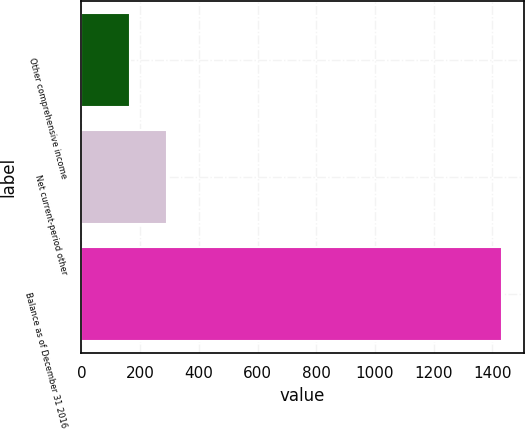Convert chart. <chart><loc_0><loc_0><loc_500><loc_500><bar_chart><fcel>Other comprehensive income<fcel>Net current-period other<fcel>Balance as of December 31 2016<nl><fcel>165<fcel>292<fcel>1435<nl></chart> 